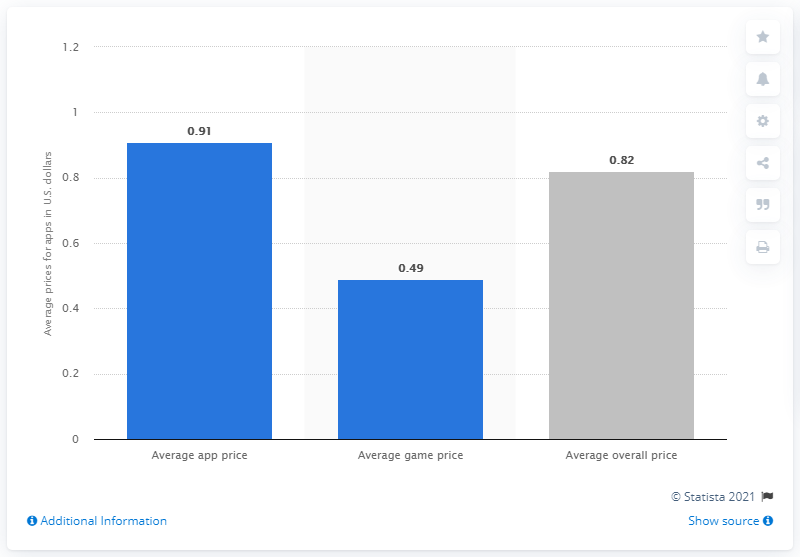Draw attention to some important aspects in this diagram. In March 2021, the average price of apps and games in the United States was 0.82 U.S. dollars. 